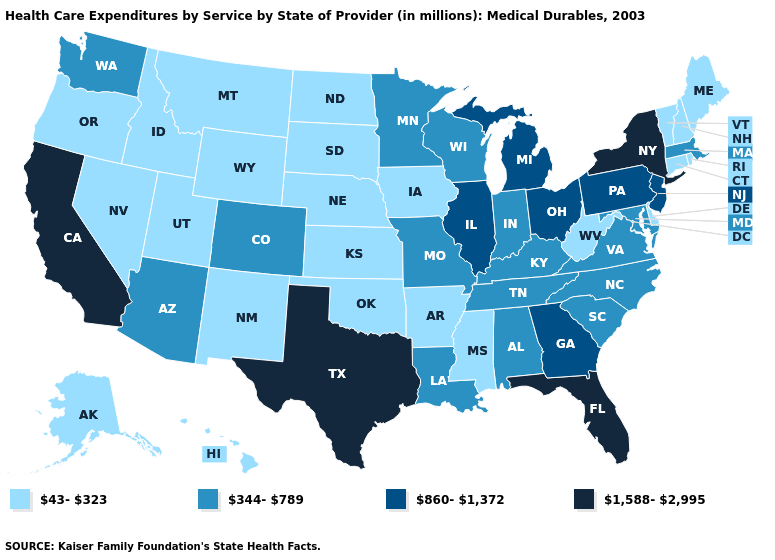Which states have the lowest value in the West?
Answer briefly. Alaska, Hawaii, Idaho, Montana, Nevada, New Mexico, Oregon, Utah, Wyoming. Does Montana have a higher value than California?
Keep it brief. No. What is the lowest value in the MidWest?
Answer briefly. 43-323. Name the states that have a value in the range 43-323?
Be succinct. Alaska, Arkansas, Connecticut, Delaware, Hawaii, Idaho, Iowa, Kansas, Maine, Mississippi, Montana, Nebraska, Nevada, New Hampshire, New Mexico, North Dakota, Oklahoma, Oregon, Rhode Island, South Dakota, Utah, Vermont, West Virginia, Wyoming. What is the highest value in the MidWest ?
Keep it brief. 860-1,372. Name the states that have a value in the range 860-1,372?
Quick response, please. Georgia, Illinois, Michigan, New Jersey, Ohio, Pennsylvania. Does Florida have the lowest value in the South?
Short answer required. No. Which states have the highest value in the USA?
Concise answer only. California, Florida, New York, Texas. Which states hav the highest value in the Northeast?
Answer briefly. New York. Which states hav the highest value in the South?
Give a very brief answer. Florida, Texas. Is the legend a continuous bar?
Quick response, please. No. Name the states that have a value in the range 43-323?
Short answer required. Alaska, Arkansas, Connecticut, Delaware, Hawaii, Idaho, Iowa, Kansas, Maine, Mississippi, Montana, Nebraska, Nevada, New Hampshire, New Mexico, North Dakota, Oklahoma, Oregon, Rhode Island, South Dakota, Utah, Vermont, West Virginia, Wyoming. Does the map have missing data?
Quick response, please. No. What is the lowest value in the West?
Quick response, please. 43-323. Among the states that border North Dakota , which have the highest value?
Be succinct. Minnesota. 